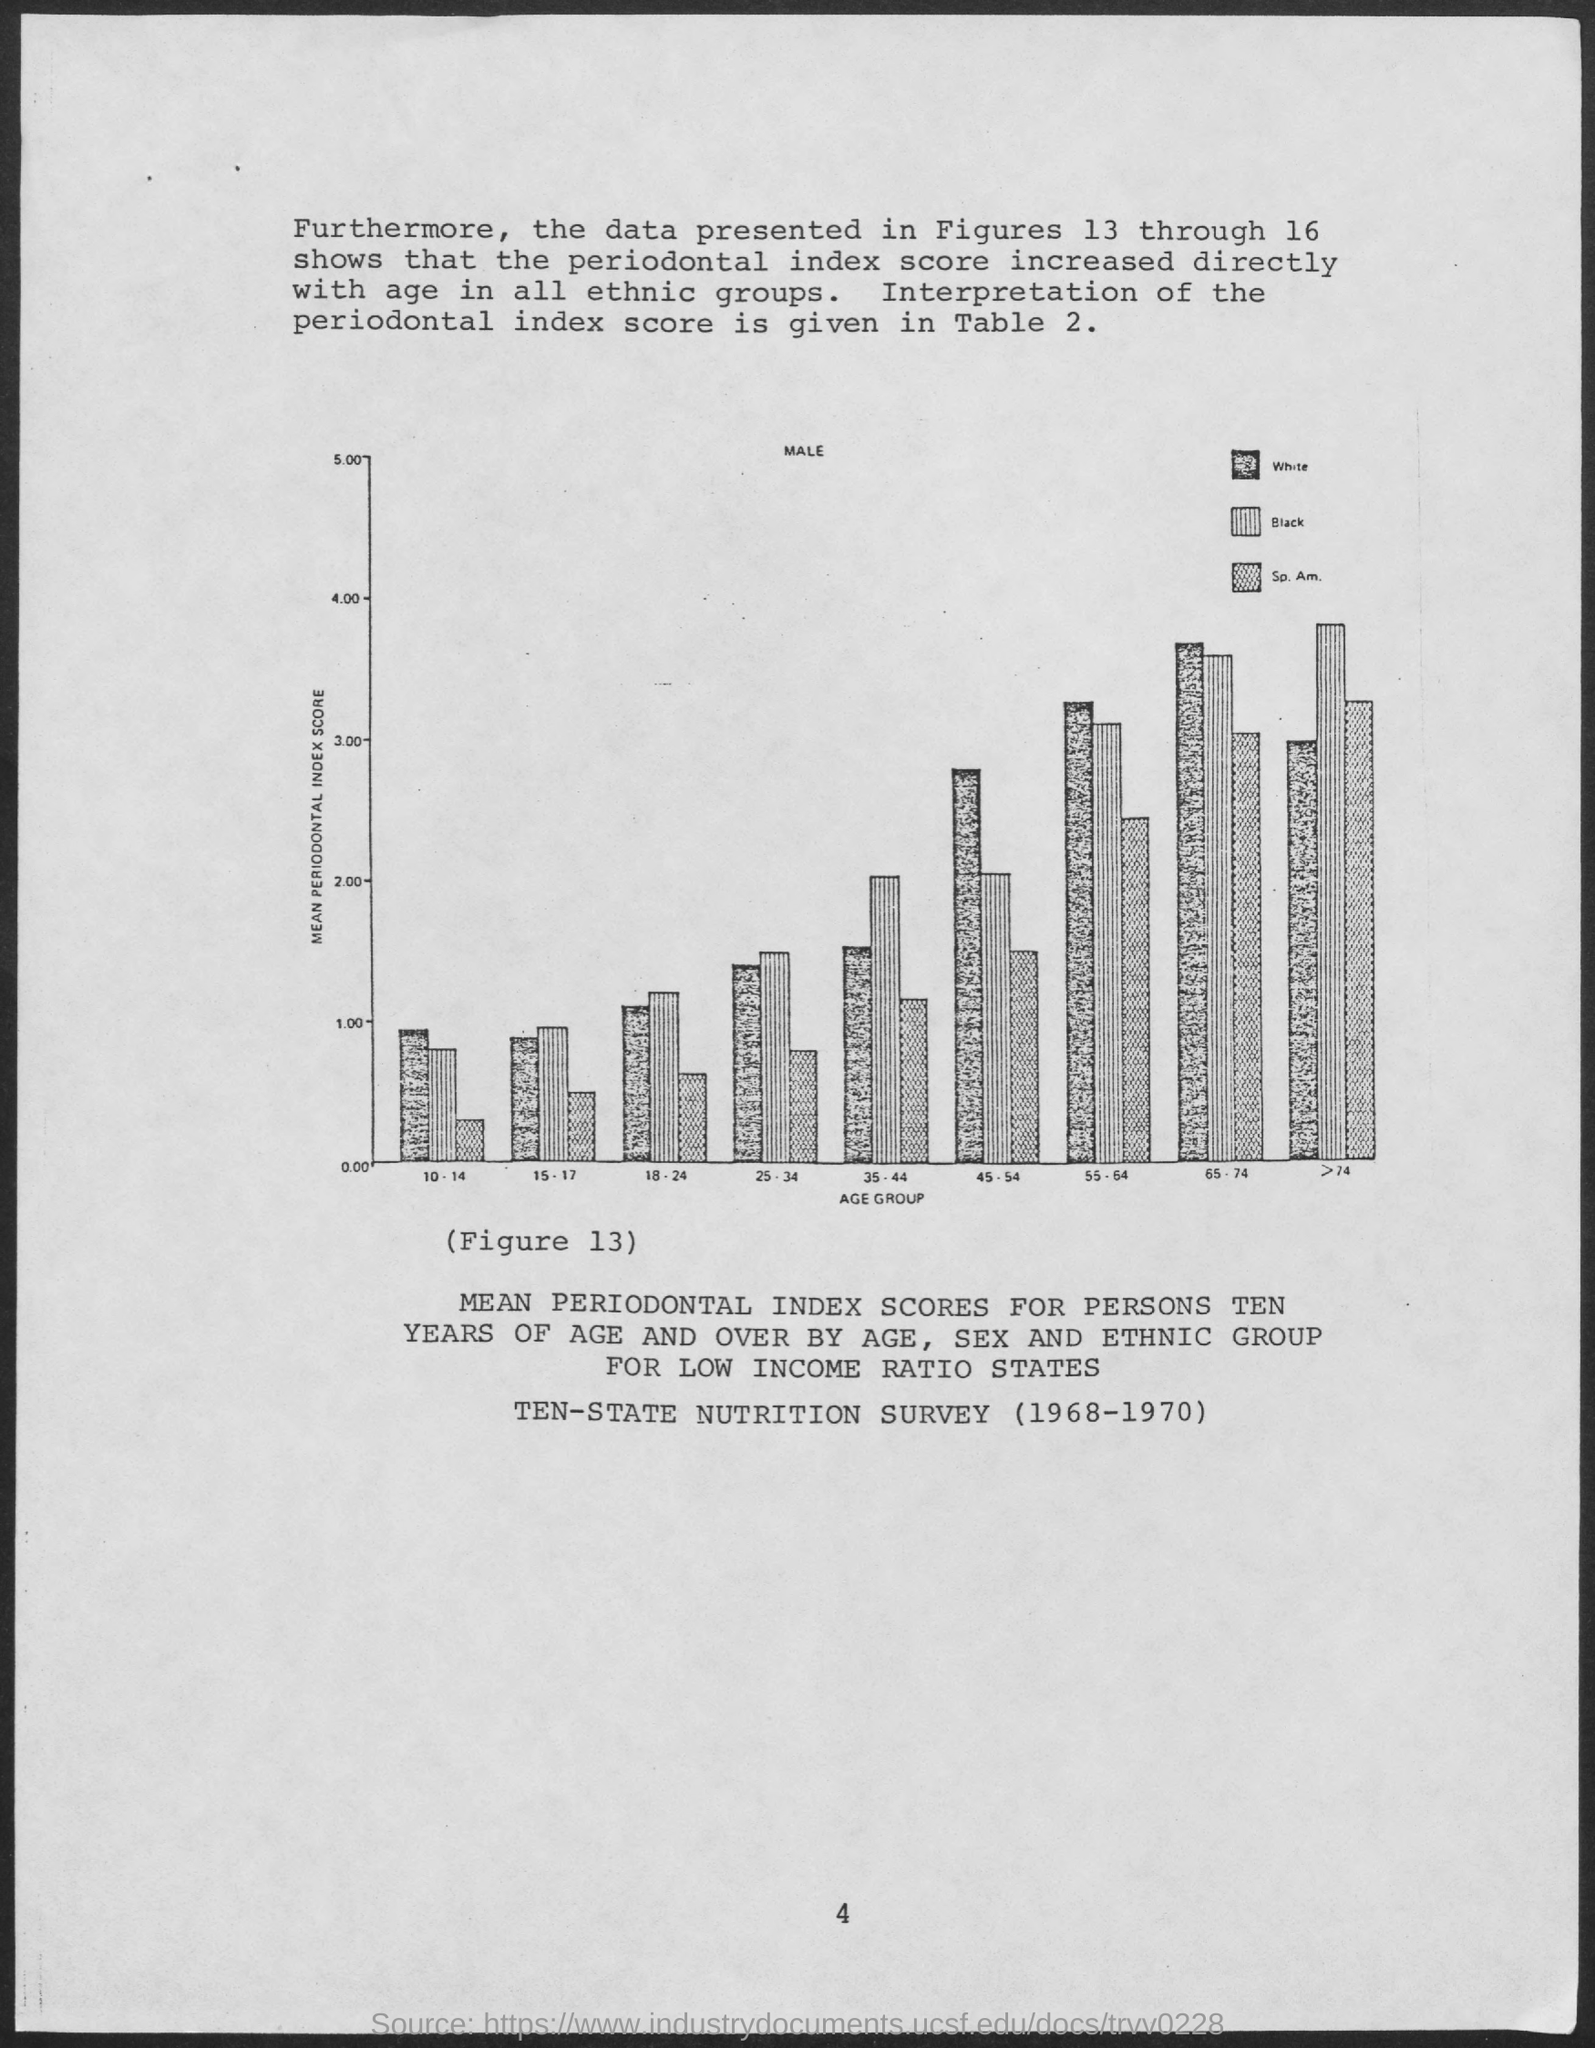What is plotted in the x-axis ?
Provide a short and direct response. Age Group. What is plotted in the y-axis?
Your answer should be very brief. Mean periodontal index score. 